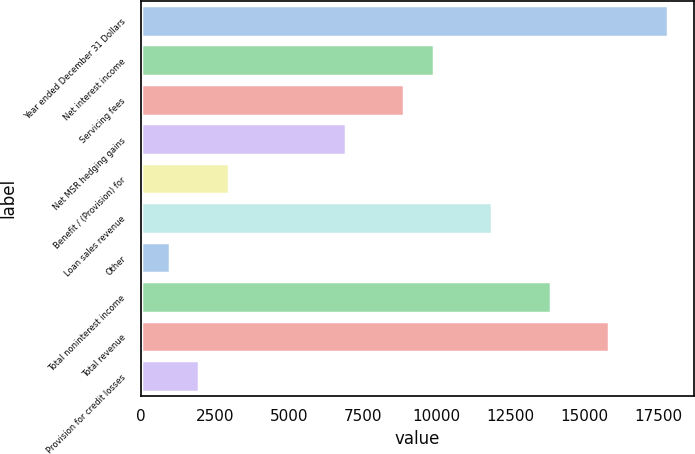<chart> <loc_0><loc_0><loc_500><loc_500><bar_chart><fcel>Year ended December 31 Dollars<fcel>Net interest income<fcel>Servicing fees<fcel>Net MSR hedging gains<fcel>Benefit / (Provision) for<fcel>Loan sales revenue<fcel>Other<fcel>Total noninterest income<fcel>Total revenue<fcel>Provision for credit losses<nl><fcel>17811.6<fcel>9896<fcel>8906.55<fcel>6927.65<fcel>2969.85<fcel>11874.9<fcel>990.95<fcel>13853.8<fcel>15832.7<fcel>1980.4<nl></chart> 